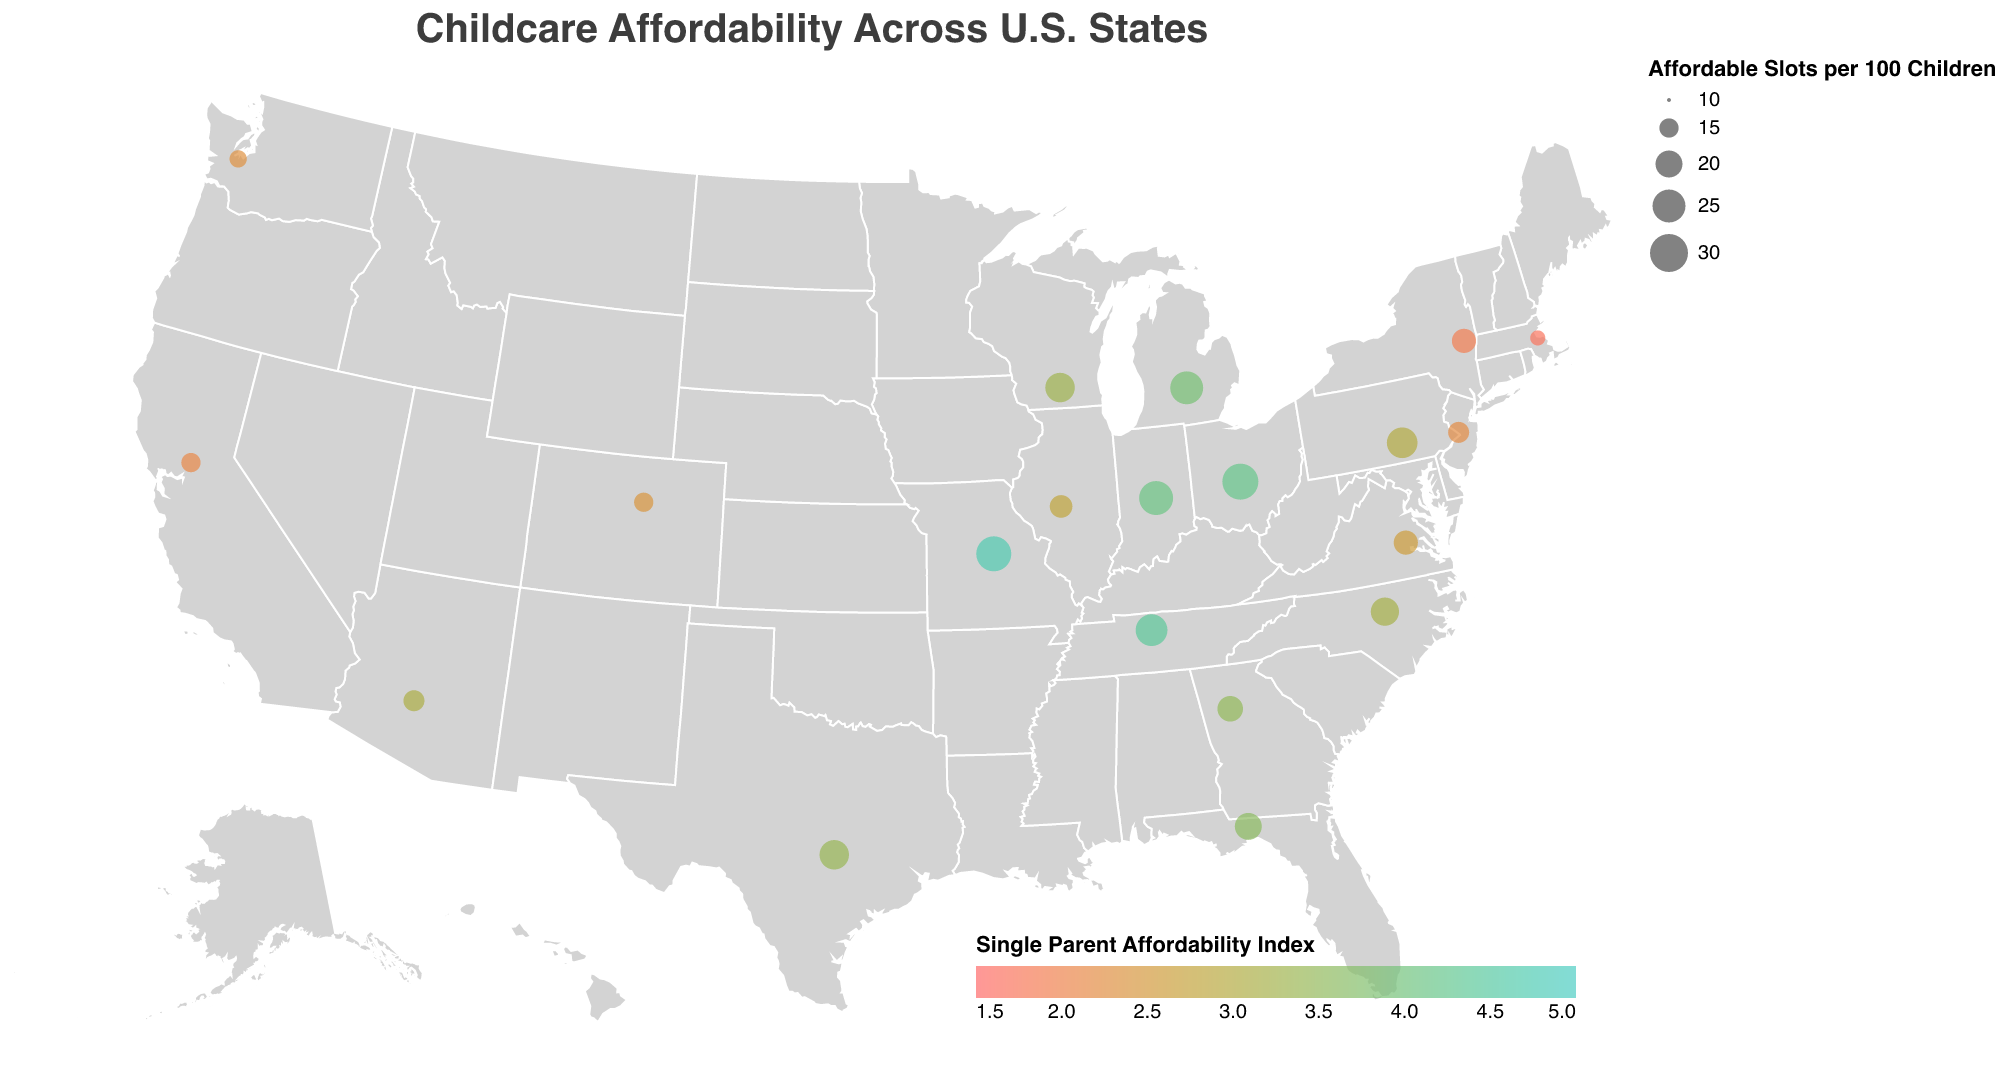What is the title of the figure? Look at the top of the figure to find the title text.
Answer: Childcare Affordability Across U.S. States Which state has the highest average monthly childcare cost? Identify the state data point with the highest value in the “Average Monthly Childcare Cost” field.
Answer: Massachusetts What color represents the highest Single Parent Affordability Index on the map? Examine the legend on the bottom-right for the color scale of the Single Parent Affordability Index.
Answer: Greenish-blue (#4ecdc4) Which state has the most affordable slots per 100 children? Identify the state data point with the highest value in the “Affordable Slots per 100 Children” field.
Answer: Ohio How much more is the average monthly childcare cost in California compared to Texas? Subtract the average monthly childcare cost in Texas from that of California (1450 - 900).
Answer: $550 Which state has the lowest Single Parent Affordability Index, and what is its average monthly childcare cost? Identify the state with the smallest value in the "Single Parent Affordability Index" and refer to its "Average Monthly Childcare Cost".
Answer: Massachusetts, $1700 Compare the average monthly childcare cost and affordable slots per 100 children between Pennsylvania and Florida. For each state, note the values of average monthly childcare cost and affordable slots per 100 children, and compare them. Pennsylvania: $1000, 23 slots; Florida: $850, 20 slots.
Answer: Pennsylvania has a higher cost and more slots than Florida How does the affordability for single parents in Washington compare to that in Virginia? Compare the Single Parent Affordability Index values for Washington and Virginia.
Answer: Washington has a lower index (2.3 vs. 2.6) than Virginia Which states have the same average monthly childcare cost? Identify pairs of states that share the same value in the “Average Monthly Childcare Cost” field.
Answer: Florida and Georgia, Ohio and Indiana What pattern can be observed from the geographic distribution of states with a Single Parent Affordability Index above 4.0? Look at the map for states with colors indicating an index above 4.0 (dark greenish-blue), and note their locations.
Answer: Most states with an index above 4.0 are found in the Midwest and South regions 